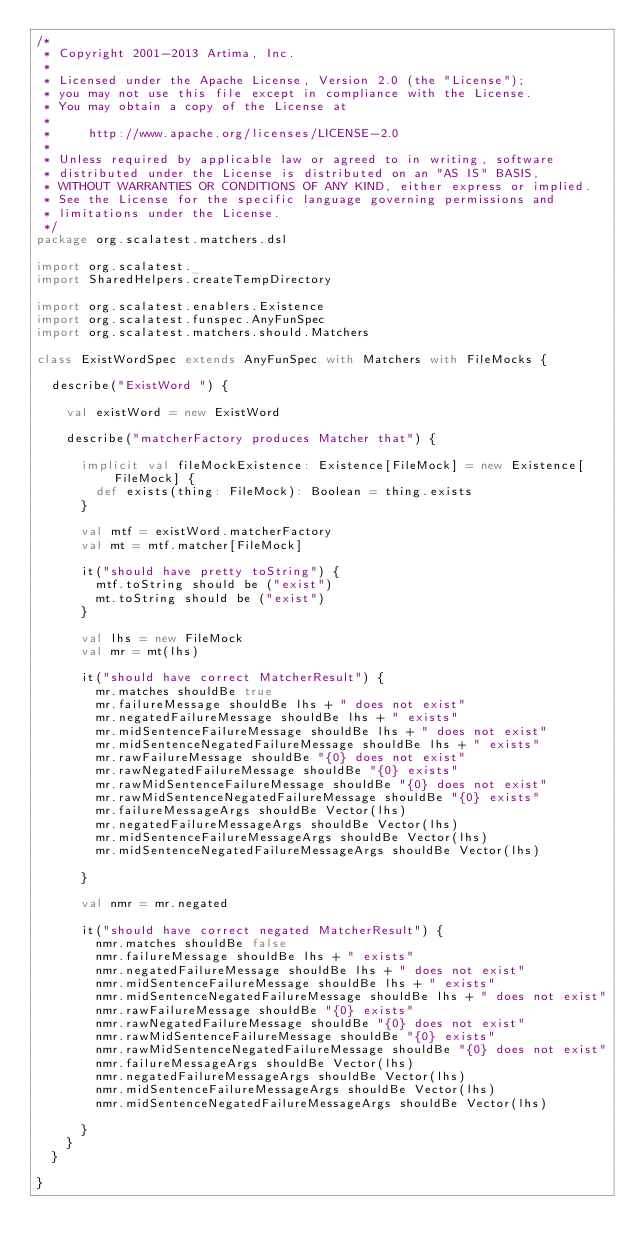Convert code to text. <code><loc_0><loc_0><loc_500><loc_500><_Scala_>/*
 * Copyright 2001-2013 Artima, Inc.
 *
 * Licensed under the Apache License, Version 2.0 (the "License");
 * you may not use this file except in compliance with the License.
 * You may obtain a copy of the License at
 *
 *     http://www.apache.org/licenses/LICENSE-2.0
 *
 * Unless required by applicable law or agreed to in writing, software
 * distributed under the License is distributed on an "AS IS" BASIS,
 * WITHOUT WARRANTIES OR CONDITIONS OF ANY KIND, either express or implied.
 * See the License for the specific language governing permissions and
 * limitations under the License.
 */
package org.scalatest.matchers.dsl

import org.scalatest._
import SharedHelpers.createTempDirectory

import org.scalatest.enablers.Existence
import org.scalatest.funspec.AnyFunSpec
import org.scalatest.matchers.should.Matchers

class ExistWordSpec extends AnyFunSpec with Matchers with FileMocks {
  
  describe("ExistWord ") {
    
    val existWord = new ExistWord
    
    describe("matcherFactory produces Matcher that") {

      implicit val fileMockExistence: Existence[FileMock] = new Existence[FileMock] {
        def exists(thing: FileMock): Boolean = thing.exists
      }

      val mtf = existWord.matcherFactory
      val mt = mtf.matcher[FileMock]
      
      it("should have pretty toString") {
        mtf.toString should be ("exist")
        mt.toString should be ("exist")
      }

      val lhs = new FileMock
      val mr = mt(lhs)
      
      it("should have correct MatcherResult") {
        mr.matches shouldBe true
        mr.failureMessage shouldBe lhs + " does not exist"
        mr.negatedFailureMessage shouldBe lhs + " exists"
        mr.midSentenceFailureMessage shouldBe lhs + " does not exist"
        mr.midSentenceNegatedFailureMessage shouldBe lhs + " exists"
        mr.rawFailureMessage shouldBe "{0} does not exist"
        mr.rawNegatedFailureMessage shouldBe "{0} exists"
        mr.rawMidSentenceFailureMessage shouldBe "{0} does not exist"
        mr.rawMidSentenceNegatedFailureMessage shouldBe "{0} exists"
        mr.failureMessageArgs shouldBe Vector(lhs)
        mr.negatedFailureMessageArgs shouldBe Vector(lhs)
        mr.midSentenceFailureMessageArgs shouldBe Vector(lhs)
        mr.midSentenceNegatedFailureMessageArgs shouldBe Vector(lhs)

      }
      
      val nmr = mr.negated
      
      it("should have correct negated MatcherResult") {
        nmr.matches shouldBe false
        nmr.failureMessage shouldBe lhs + " exists"
        nmr.negatedFailureMessage shouldBe lhs + " does not exist"
        nmr.midSentenceFailureMessage shouldBe lhs + " exists"
        nmr.midSentenceNegatedFailureMessage shouldBe lhs + " does not exist"
        nmr.rawFailureMessage shouldBe "{0} exists"
        nmr.rawNegatedFailureMessage shouldBe "{0} does not exist"
        nmr.rawMidSentenceFailureMessage shouldBe "{0} exists"
        nmr.rawMidSentenceNegatedFailureMessage shouldBe "{0} does not exist"
        nmr.failureMessageArgs shouldBe Vector(lhs)
        nmr.negatedFailureMessageArgs shouldBe Vector(lhs)
        nmr.midSentenceFailureMessageArgs shouldBe Vector(lhs)
        nmr.midSentenceNegatedFailureMessageArgs shouldBe Vector(lhs)

      }
    }
  }
  
}
</code> 